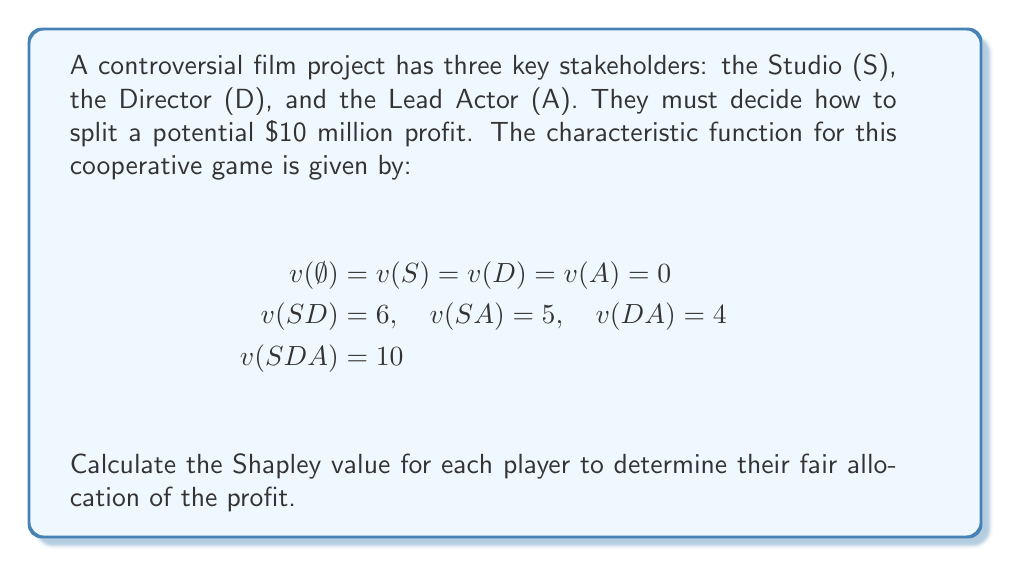Help me with this question. To calculate the Shapley value, we need to determine each player's marginal contribution in all possible coalition formations:

1. Calculate marginal contributions for each player:

   S: (0-0) + (6-0) + (5-0) + (10-4) = 17
   D: (0-0) + (6-0) + (4-0) + (10-5) = 15
   A: (0-0) + (5-0) + (4-0) + (10-6) = 13

2. Count the number of orderings for each marginal contribution:

   S: 1 + 1 + 1 + 3 = 6
   D: 1 + 1 + 1 + 3 = 6
   A: 1 + 1 + 1 + 3 = 6

3. Calculate the Shapley value for each player:

   $$\phi_S = \frac{17}{6} = \frac{17}{6}$$
   $$\phi_D = \frac{15}{6} = \frac{5}{2}$$
   $$\phi_A = \frac{13}{6}$$

4. Verify that the sum of Shapley values equals the total value:

   $$\frac{17}{6} + \frac{5}{2} + \frac{13}{6} = \frac{17+15+13}{6} = \frac{45}{6} = \frac{15}{2} = 7.5$$

   This equals the total value of 10 - 2.5 = 7.5, confirming our calculation.
Answer: Studio: $\frac{17}{6}$ million, Director: $\frac{5}{2}$ million, Actor: $\frac{13}{6}$ million 